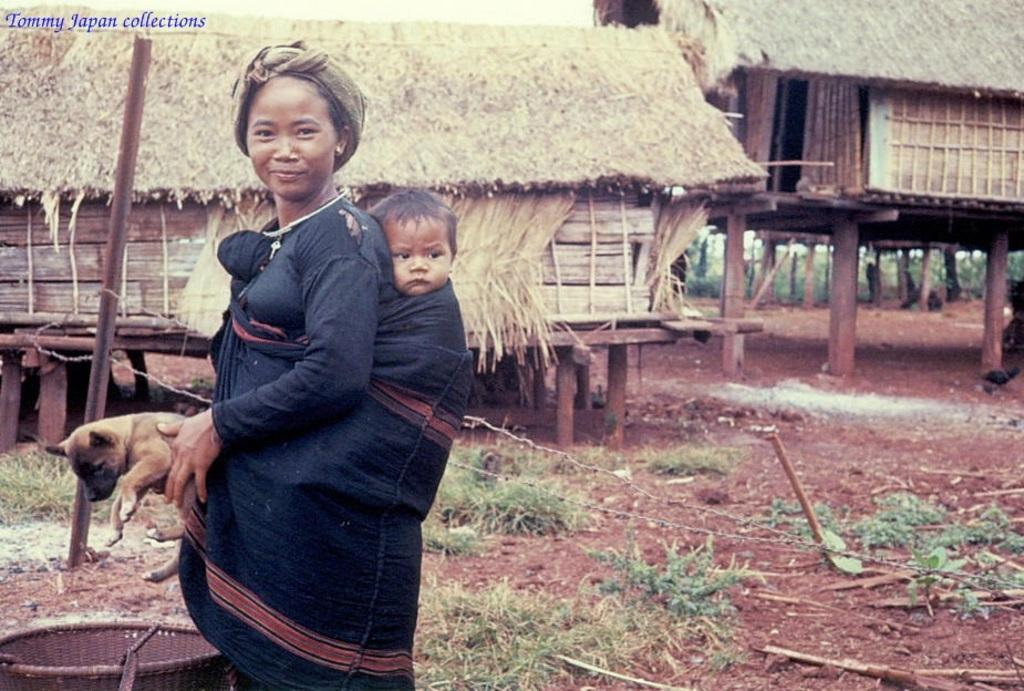Who is the main subject in the image? There is a woman in the image. What is the woman doing in the image? The woman is carrying a baby and holding a dog. What is the woman's facial expression in the image? The woman is smiling in the image. What can be seen in the background of the image? There is a hut in the background of the image. What type of produce is being transported in the carriage in the image? There is no carriage or produce present in the image. Is the woman wearing a winter coat in the image? The provided facts do not mention the weather or the woman's clothing, so it cannot be determined if she is wearing a winter coat. 